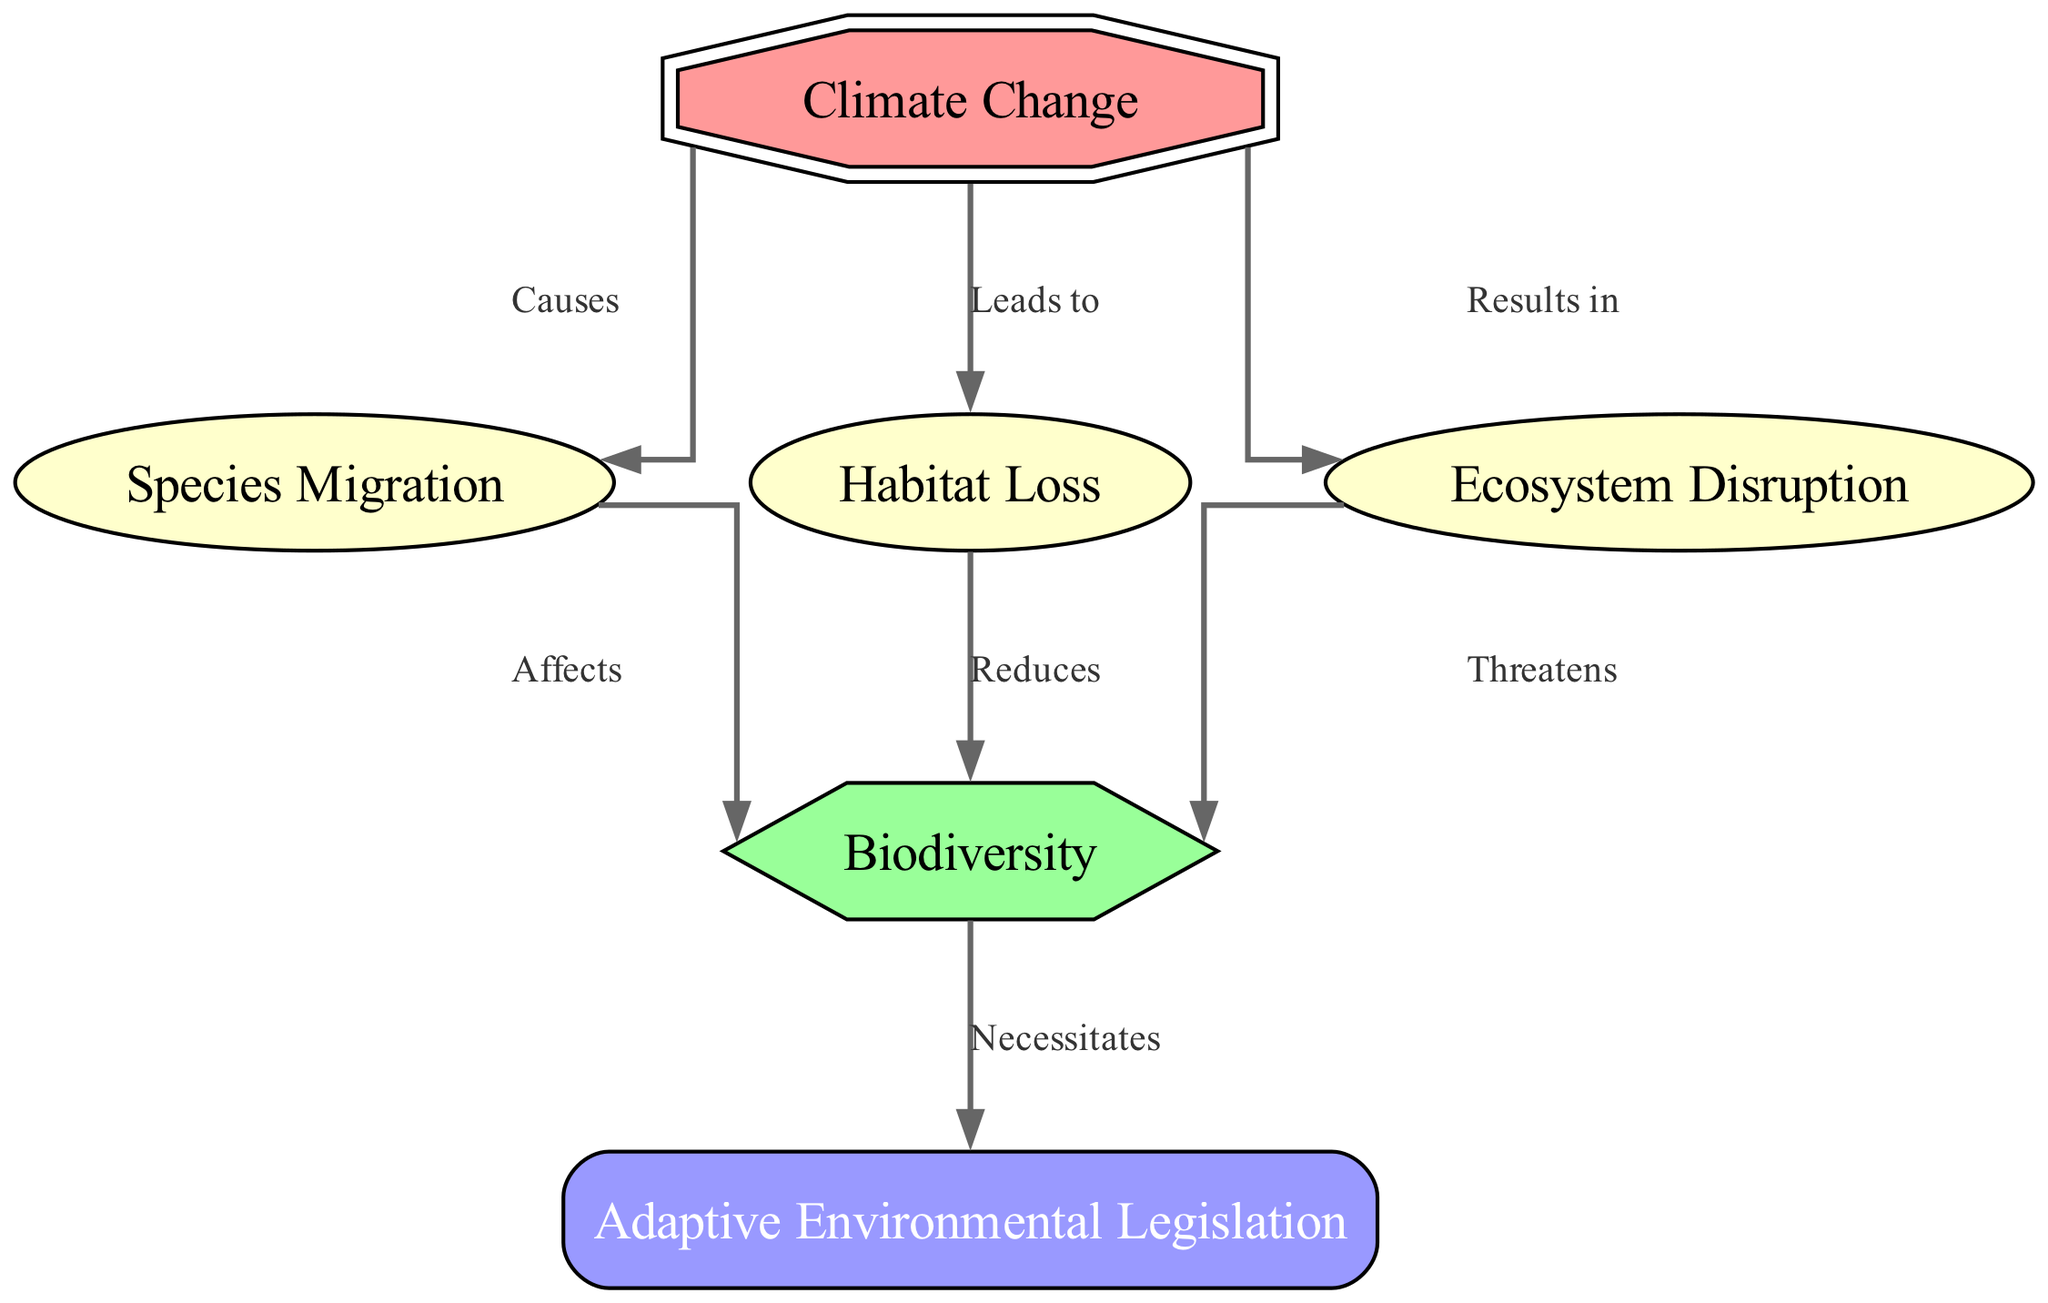What are the two main impacts of climate change on biodiversity shown in the diagram? The diagram indicates that climate change leads to habitat loss and species migration, both of which impact biodiversity.
Answer: Habitat loss, Species migration How many nodes are present in the diagram? The diagram includes six distinct nodes: climate change, biodiversity, species migration, habitat loss, ecosystem disruption, and adaptive environmental legislation.
Answer: 6 Which node is affected by both habitat loss and ecosystem disruption? Biodiversity is affected by both habitat loss, which reduces biodiversity, and ecosystem disruption, which threatens it.
Answer: Biodiversity What does biodiversity necessitate according to the diagram? The diagram shows that biodiversity necessitates adaptive environmental legislation to address the impacts from climate change and its consequences.
Answer: Adaptive Environmental Legislation What is the relationship between climate change and species migration? The diagram establishes a direct causal relationship where climate change causes species migration, indicating a flow of impact from climate change to the movement of species.
Answer: Causes How does ecosystem disruption impact biodiversity? Ecosystem disruption threatens biodiversity, demonstrating a negative impact that could lead to reduced species diversity and ecological stability.
Answer: Threatens What type of legislation is indicated as necessary in response to climate change impacts on biodiversity? The diagram specifies that adaptive environmental legislation is necessary to address the evolving challenges posed by climate change on biodiversity.
Answer: Adaptive Environmental Legislation Which node is portrayed as a hub for negative impacts stemming from climate change in the diagram? Biodiversity acts as a hub that is negatively impacted by all mentioned causes from climate change, including habitat loss and species migration.
Answer: Biodiversity What is the overall theme represented in the diagram? The overall theme represented in the diagram emphasizes the interconnectedness of climate change, its impacts on biodiversity, and the urgent need for adaptive environmental legislation.
Answer: Interconnectedness 